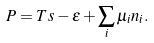Convert formula to latex. <formula><loc_0><loc_0><loc_500><loc_500>P = T s - \epsilon + \sum _ { i } \mu _ { i } n _ { i } .</formula> 